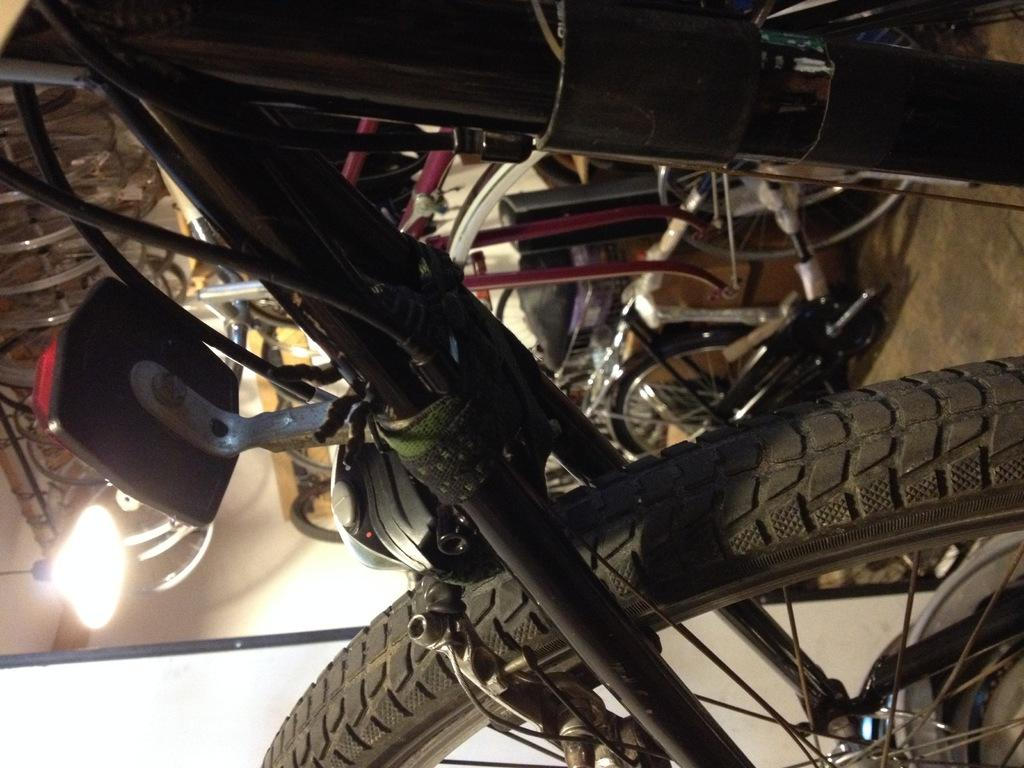What is the main object in the front of the image? There is a bicycle in the front of the image. What can be seen in the background of the image? There is a wall and additional bicycles in the background of the image. Where is the light located in the image? The light is on the left side of the image. What type of cracker is being used to fix the bicycle in the image? There is no cracker present in the image, nor is there any indication that the bicycle needs fixing. 